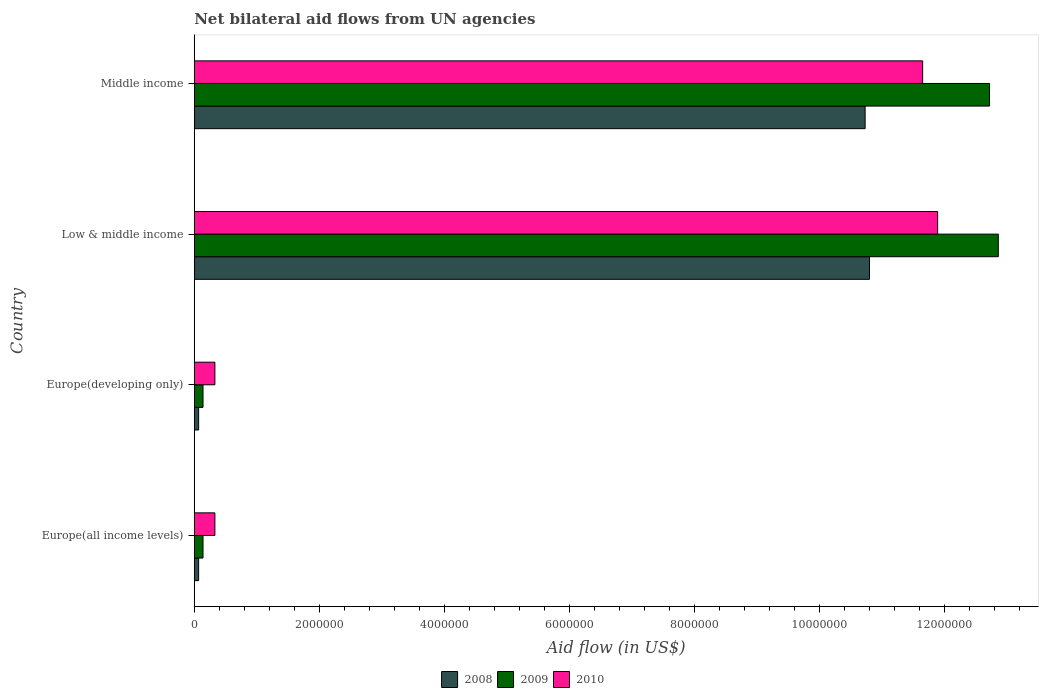How many groups of bars are there?
Give a very brief answer. 4. Are the number of bars per tick equal to the number of legend labels?
Keep it short and to the point. Yes. How many bars are there on the 3rd tick from the top?
Provide a succinct answer. 3. What is the label of the 3rd group of bars from the top?
Keep it short and to the point. Europe(developing only). What is the net bilateral aid flow in 2009 in Low & middle income?
Ensure brevity in your answer.  1.29e+07. Across all countries, what is the maximum net bilateral aid flow in 2010?
Provide a short and direct response. 1.19e+07. In which country was the net bilateral aid flow in 2009 minimum?
Offer a terse response. Europe(all income levels). What is the total net bilateral aid flow in 2008 in the graph?
Offer a terse response. 2.17e+07. What is the difference between the net bilateral aid flow in 2009 in Low & middle income and that in Middle income?
Ensure brevity in your answer.  1.40e+05. What is the difference between the net bilateral aid flow in 2009 in Middle income and the net bilateral aid flow in 2010 in Europe(all income levels)?
Your answer should be compact. 1.24e+07. What is the average net bilateral aid flow in 2008 per country?
Give a very brief answer. 5.42e+06. What is the difference between the net bilateral aid flow in 2008 and net bilateral aid flow in 2009 in Middle income?
Your answer should be very brief. -1.99e+06. In how many countries, is the net bilateral aid flow in 2008 greater than 12000000 US$?
Make the answer very short. 0. What is the difference between the highest and the second highest net bilateral aid flow in 2009?
Ensure brevity in your answer.  1.40e+05. What is the difference between the highest and the lowest net bilateral aid flow in 2009?
Your answer should be very brief. 1.27e+07. In how many countries, is the net bilateral aid flow in 2009 greater than the average net bilateral aid flow in 2009 taken over all countries?
Ensure brevity in your answer.  2. Is the sum of the net bilateral aid flow in 2008 in Europe(all income levels) and Low & middle income greater than the maximum net bilateral aid flow in 2010 across all countries?
Provide a short and direct response. No. What does the 2nd bar from the top in Middle income represents?
Make the answer very short. 2009. Are all the bars in the graph horizontal?
Keep it short and to the point. Yes. What is the difference between two consecutive major ticks on the X-axis?
Make the answer very short. 2.00e+06. Are the values on the major ticks of X-axis written in scientific E-notation?
Give a very brief answer. No. Does the graph contain any zero values?
Keep it short and to the point. No. How are the legend labels stacked?
Offer a terse response. Horizontal. What is the title of the graph?
Keep it short and to the point. Net bilateral aid flows from UN agencies. Does "1968" appear as one of the legend labels in the graph?
Your answer should be compact. No. What is the label or title of the X-axis?
Your response must be concise. Aid flow (in US$). What is the Aid flow (in US$) of 2008 in Europe(all income levels)?
Your answer should be very brief. 7.00e+04. What is the Aid flow (in US$) of 2009 in Europe(developing only)?
Give a very brief answer. 1.40e+05. What is the Aid flow (in US$) of 2008 in Low & middle income?
Provide a succinct answer. 1.08e+07. What is the Aid flow (in US$) in 2009 in Low & middle income?
Keep it short and to the point. 1.29e+07. What is the Aid flow (in US$) in 2010 in Low & middle income?
Your answer should be compact. 1.19e+07. What is the Aid flow (in US$) of 2008 in Middle income?
Give a very brief answer. 1.07e+07. What is the Aid flow (in US$) in 2009 in Middle income?
Keep it short and to the point. 1.27e+07. What is the Aid flow (in US$) of 2010 in Middle income?
Your answer should be very brief. 1.16e+07. Across all countries, what is the maximum Aid flow (in US$) of 2008?
Make the answer very short. 1.08e+07. Across all countries, what is the maximum Aid flow (in US$) in 2009?
Offer a terse response. 1.29e+07. Across all countries, what is the maximum Aid flow (in US$) in 2010?
Your answer should be compact. 1.19e+07. Across all countries, what is the minimum Aid flow (in US$) in 2008?
Give a very brief answer. 7.00e+04. Across all countries, what is the minimum Aid flow (in US$) of 2010?
Give a very brief answer. 3.30e+05. What is the total Aid flow (in US$) of 2008 in the graph?
Your response must be concise. 2.17e+07. What is the total Aid flow (in US$) of 2009 in the graph?
Provide a short and direct response. 2.59e+07. What is the total Aid flow (in US$) in 2010 in the graph?
Offer a terse response. 2.42e+07. What is the difference between the Aid flow (in US$) of 2008 in Europe(all income levels) and that in Europe(developing only)?
Give a very brief answer. 0. What is the difference between the Aid flow (in US$) in 2010 in Europe(all income levels) and that in Europe(developing only)?
Provide a succinct answer. 0. What is the difference between the Aid flow (in US$) in 2008 in Europe(all income levels) and that in Low & middle income?
Offer a terse response. -1.07e+07. What is the difference between the Aid flow (in US$) in 2009 in Europe(all income levels) and that in Low & middle income?
Give a very brief answer. -1.27e+07. What is the difference between the Aid flow (in US$) of 2010 in Europe(all income levels) and that in Low & middle income?
Give a very brief answer. -1.16e+07. What is the difference between the Aid flow (in US$) of 2008 in Europe(all income levels) and that in Middle income?
Provide a succinct answer. -1.07e+07. What is the difference between the Aid flow (in US$) in 2009 in Europe(all income levels) and that in Middle income?
Keep it short and to the point. -1.26e+07. What is the difference between the Aid flow (in US$) in 2010 in Europe(all income levels) and that in Middle income?
Keep it short and to the point. -1.13e+07. What is the difference between the Aid flow (in US$) in 2008 in Europe(developing only) and that in Low & middle income?
Your answer should be compact. -1.07e+07. What is the difference between the Aid flow (in US$) of 2009 in Europe(developing only) and that in Low & middle income?
Ensure brevity in your answer.  -1.27e+07. What is the difference between the Aid flow (in US$) in 2010 in Europe(developing only) and that in Low & middle income?
Your answer should be very brief. -1.16e+07. What is the difference between the Aid flow (in US$) in 2008 in Europe(developing only) and that in Middle income?
Ensure brevity in your answer.  -1.07e+07. What is the difference between the Aid flow (in US$) of 2009 in Europe(developing only) and that in Middle income?
Your answer should be very brief. -1.26e+07. What is the difference between the Aid flow (in US$) in 2010 in Europe(developing only) and that in Middle income?
Your answer should be compact. -1.13e+07. What is the difference between the Aid flow (in US$) of 2008 in Low & middle income and that in Middle income?
Offer a very short reply. 7.00e+04. What is the difference between the Aid flow (in US$) in 2010 in Low & middle income and that in Middle income?
Offer a very short reply. 2.40e+05. What is the difference between the Aid flow (in US$) of 2008 in Europe(all income levels) and the Aid flow (in US$) of 2009 in Europe(developing only)?
Your response must be concise. -7.00e+04. What is the difference between the Aid flow (in US$) in 2009 in Europe(all income levels) and the Aid flow (in US$) in 2010 in Europe(developing only)?
Offer a terse response. -1.90e+05. What is the difference between the Aid flow (in US$) of 2008 in Europe(all income levels) and the Aid flow (in US$) of 2009 in Low & middle income?
Give a very brief answer. -1.28e+07. What is the difference between the Aid flow (in US$) in 2008 in Europe(all income levels) and the Aid flow (in US$) in 2010 in Low & middle income?
Your response must be concise. -1.18e+07. What is the difference between the Aid flow (in US$) of 2009 in Europe(all income levels) and the Aid flow (in US$) of 2010 in Low & middle income?
Offer a terse response. -1.18e+07. What is the difference between the Aid flow (in US$) of 2008 in Europe(all income levels) and the Aid flow (in US$) of 2009 in Middle income?
Give a very brief answer. -1.26e+07. What is the difference between the Aid flow (in US$) in 2008 in Europe(all income levels) and the Aid flow (in US$) in 2010 in Middle income?
Offer a terse response. -1.16e+07. What is the difference between the Aid flow (in US$) of 2009 in Europe(all income levels) and the Aid flow (in US$) of 2010 in Middle income?
Offer a very short reply. -1.15e+07. What is the difference between the Aid flow (in US$) in 2008 in Europe(developing only) and the Aid flow (in US$) in 2009 in Low & middle income?
Offer a terse response. -1.28e+07. What is the difference between the Aid flow (in US$) in 2008 in Europe(developing only) and the Aid flow (in US$) in 2010 in Low & middle income?
Offer a very short reply. -1.18e+07. What is the difference between the Aid flow (in US$) of 2009 in Europe(developing only) and the Aid flow (in US$) of 2010 in Low & middle income?
Provide a short and direct response. -1.18e+07. What is the difference between the Aid flow (in US$) in 2008 in Europe(developing only) and the Aid flow (in US$) in 2009 in Middle income?
Your response must be concise. -1.26e+07. What is the difference between the Aid flow (in US$) in 2008 in Europe(developing only) and the Aid flow (in US$) in 2010 in Middle income?
Offer a terse response. -1.16e+07. What is the difference between the Aid flow (in US$) in 2009 in Europe(developing only) and the Aid flow (in US$) in 2010 in Middle income?
Your answer should be very brief. -1.15e+07. What is the difference between the Aid flow (in US$) of 2008 in Low & middle income and the Aid flow (in US$) of 2009 in Middle income?
Ensure brevity in your answer.  -1.92e+06. What is the difference between the Aid flow (in US$) of 2008 in Low & middle income and the Aid flow (in US$) of 2010 in Middle income?
Your answer should be very brief. -8.50e+05. What is the difference between the Aid flow (in US$) of 2009 in Low & middle income and the Aid flow (in US$) of 2010 in Middle income?
Give a very brief answer. 1.21e+06. What is the average Aid flow (in US$) in 2008 per country?
Your answer should be very brief. 5.42e+06. What is the average Aid flow (in US$) in 2009 per country?
Offer a very short reply. 6.46e+06. What is the average Aid flow (in US$) in 2010 per country?
Keep it short and to the point. 6.05e+06. What is the difference between the Aid flow (in US$) in 2008 and Aid flow (in US$) in 2009 in Europe(all income levels)?
Give a very brief answer. -7.00e+04. What is the difference between the Aid flow (in US$) in 2009 and Aid flow (in US$) in 2010 in Europe(all income levels)?
Give a very brief answer. -1.90e+05. What is the difference between the Aid flow (in US$) of 2008 and Aid flow (in US$) of 2009 in Low & middle income?
Your answer should be very brief. -2.06e+06. What is the difference between the Aid flow (in US$) of 2008 and Aid flow (in US$) of 2010 in Low & middle income?
Ensure brevity in your answer.  -1.09e+06. What is the difference between the Aid flow (in US$) in 2009 and Aid flow (in US$) in 2010 in Low & middle income?
Offer a very short reply. 9.70e+05. What is the difference between the Aid flow (in US$) in 2008 and Aid flow (in US$) in 2009 in Middle income?
Your answer should be very brief. -1.99e+06. What is the difference between the Aid flow (in US$) in 2008 and Aid flow (in US$) in 2010 in Middle income?
Your response must be concise. -9.20e+05. What is the difference between the Aid flow (in US$) in 2009 and Aid flow (in US$) in 2010 in Middle income?
Keep it short and to the point. 1.07e+06. What is the ratio of the Aid flow (in US$) of 2010 in Europe(all income levels) to that in Europe(developing only)?
Your answer should be very brief. 1. What is the ratio of the Aid flow (in US$) in 2008 in Europe(all income levels) to that in Low & middle income?
Your answer should be very brief. 0.01. What is the ratio of the Aid flow (in US$) of 2009 in Europe(all income levels) to that in Low & middle income?
Your answer should be compact. 0.01. What is the ratio of the Aid flow (in US$) in 2010 in Europe(all income levels) to that in Low & middle income?
Your answer should be very brief. 0.03. What is the ratio of the Aid flow (in US$) in 2008 in Europe(all income levels) to that in Middle income?
Ensure brevity in your answer.  0.01. What is the ratio of the Aid flow (in US$) of 2009 in Europe(all income levels) to that in Middle income?
Offer a very short reply. 0.01. What is the ratio of the Aid flow (in US$) in 2010 in Europe(all income levels) to that in Middle income?
Your answer should be very brief. 0.03. What is the ratio of the Aid flow (in US$) of 2008 in Europe(developing only) to that in Low & middle income?
Make the answer very short. 0.01. What is the ratio of the Aid flow (in US$) of 2009 in Europe(developing only) to that in Low & middle income?
Make the answer very short. 0.01. What is the ratio of the Aid flow (in US$) of 2010 in Europe(developing only) to that in Low & middle income?
Offer a very short reply. 0.03. What is the ratio of the Aid flow (in US$) in 2008 in Europe(developing only) to that in Middle income?
Ensure brevity in your answer.  0.01. What is the ratio of the Aid flow (in US$) of 2009 in Europe(developing only) to that in Middle income?
Your answer should be very brief. 0.01. What is the ratio of the Aid flow (in US$) of 2010 in Europe(developing only) to that in Middle income?
Provide a succinct answer. 0.03. What is the ratio of the Aid flow (in US$) in 2010 in Low & middle income to that in Middle income?
Offer a very short reply. 1.02. What is the difference between the highest and the lowest Aid flow (in US$) in 2008?
Offer a very short reply. 1.07e+07. What is the difference between the highest and the lowest Aid flow (in US$) in 2009?
Keep it short and to the point. 1.27e+07. What is the difference between the highest and the lowest Aid flow (in US$) in 2010?
Your answer should be compact. 1.16e+07. 